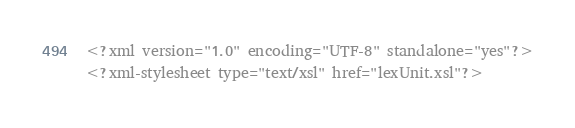<code> <loc_0><loc_0><loc_500><loc_500><_XML_><?xml version="1.0" encoding="UTF-8" standalone="yes"?>
<?xml-stylesheet type="text/xsl" href="lexUnit.xsl"?></code> 